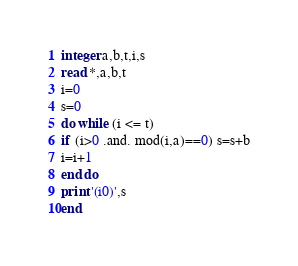Convert code to text. <code><loc_0><loc_0><loc_500><loc_500><_FORTRAN_>integer a,b,t,i,s
read *,a,b,t
i=0
s=0
do while (i <= t)
if (i>0 .and. mod(i,a)==0) s=s+b
i=i+1
end do
print '(i0)',s
end</code> 